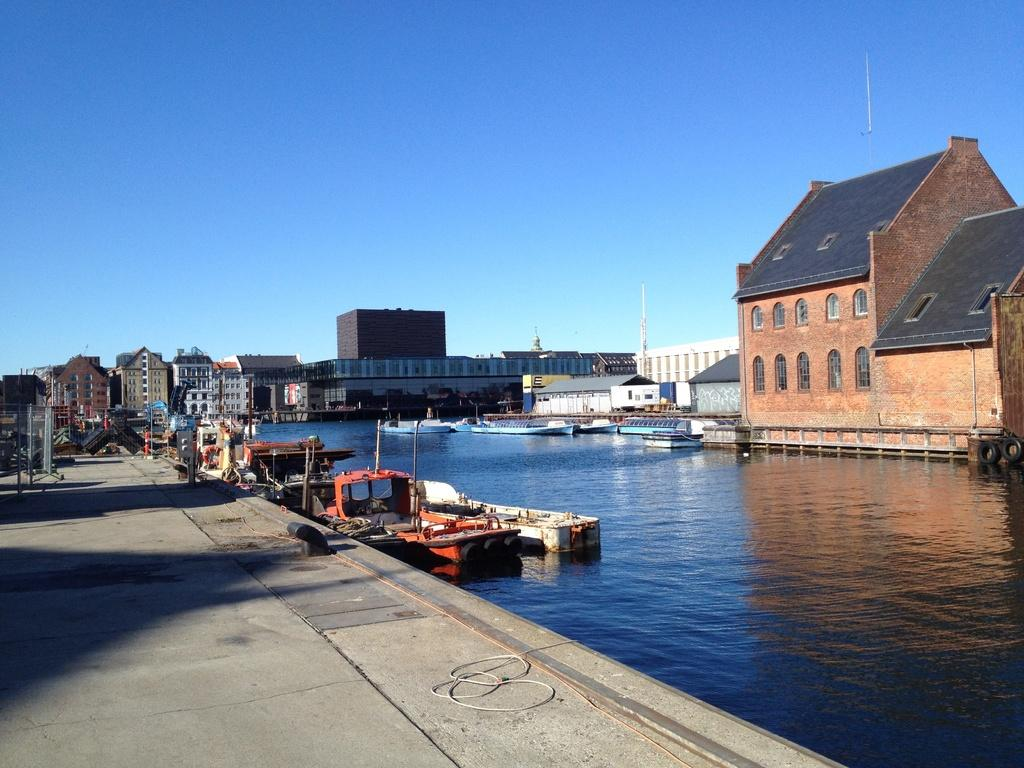What is at the bottom of the image? There is water at the bottom of the image. What can be seen floating in the water? There are many boats in the water. What is visible on the right side of the image? There are buildings on the right side of the image. What is visible in the sky in the image? The sky is visible in the image. What is visible on the left side of the image? There are buildings on the left side of the image. What is visible on the floor on the left side of the image? The floor is visible on the left side of the image. Where is the sink located in the image? There is no sink present in the image. What is the yoke used for in the image? There is no yoke present in the image. 